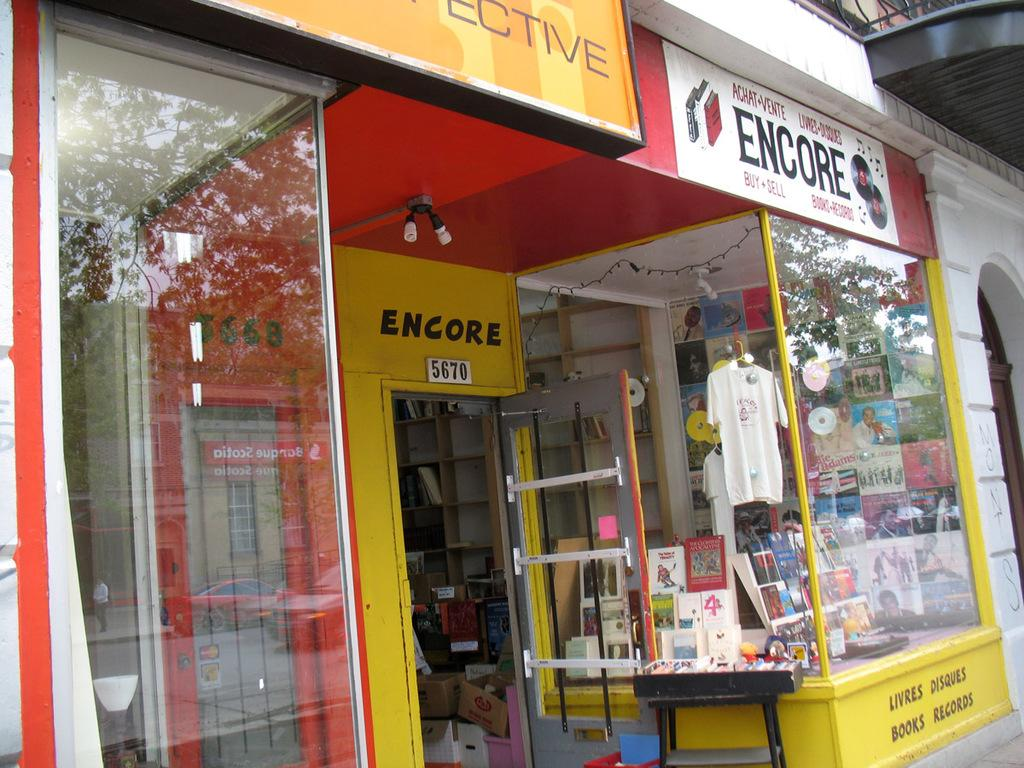<image>
Offer a succinct explanation of the picture presented. A record and book store called Encore which is at 5670. 